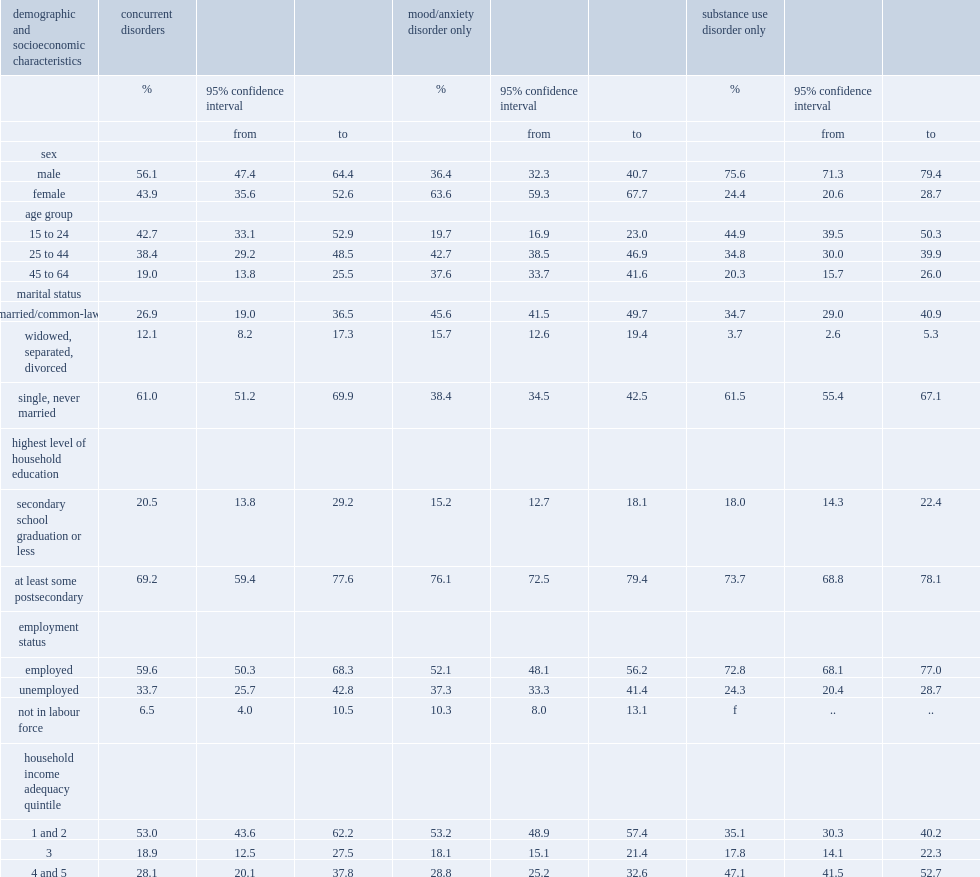Who is more likely to be single,people with concurrent disorders or people with a mood/anxiety disorder? Concurrent disorders. Who is less likely to be single,people with concurrent disorders or people with a mood/anxiety disorder? Concurrent disorders. What is the precentage of peopele with with a mood/anxiety disorder at aged 15 to 24? 19.7. Who is less likely to be employed or in the top two household income adequacy quintiles,people with substance use disorder or people with concurrent disorders? Concurrent disorders. Who is more likely in the bottom two household income quintiles,people with substance use disorder or people with concurrent disorders? Concurrent disorders. 